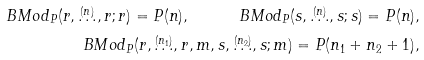<formula> <loc_0><loc_0><loc_500><loc_500>\ B M o d _ { P } ( r , \stackrel { ( n ) } { \dots } , r ; r ) = P ( n ) , \quad \ B M o d _ { P } ( s , \stackrel { ( n ) } { \dots } , s ; s ) = P ( n ) , \\ \ B M o d _ { P } ( r , \stackrel { ( n _ { 1 } ) } { \dots } , r , m , s , \stackrel { ( n _ { 2 } ) } { \dots } , s ; m ) = P ( n _ { 1 } + n _ { 2 } + 1 ) ,</formula> 